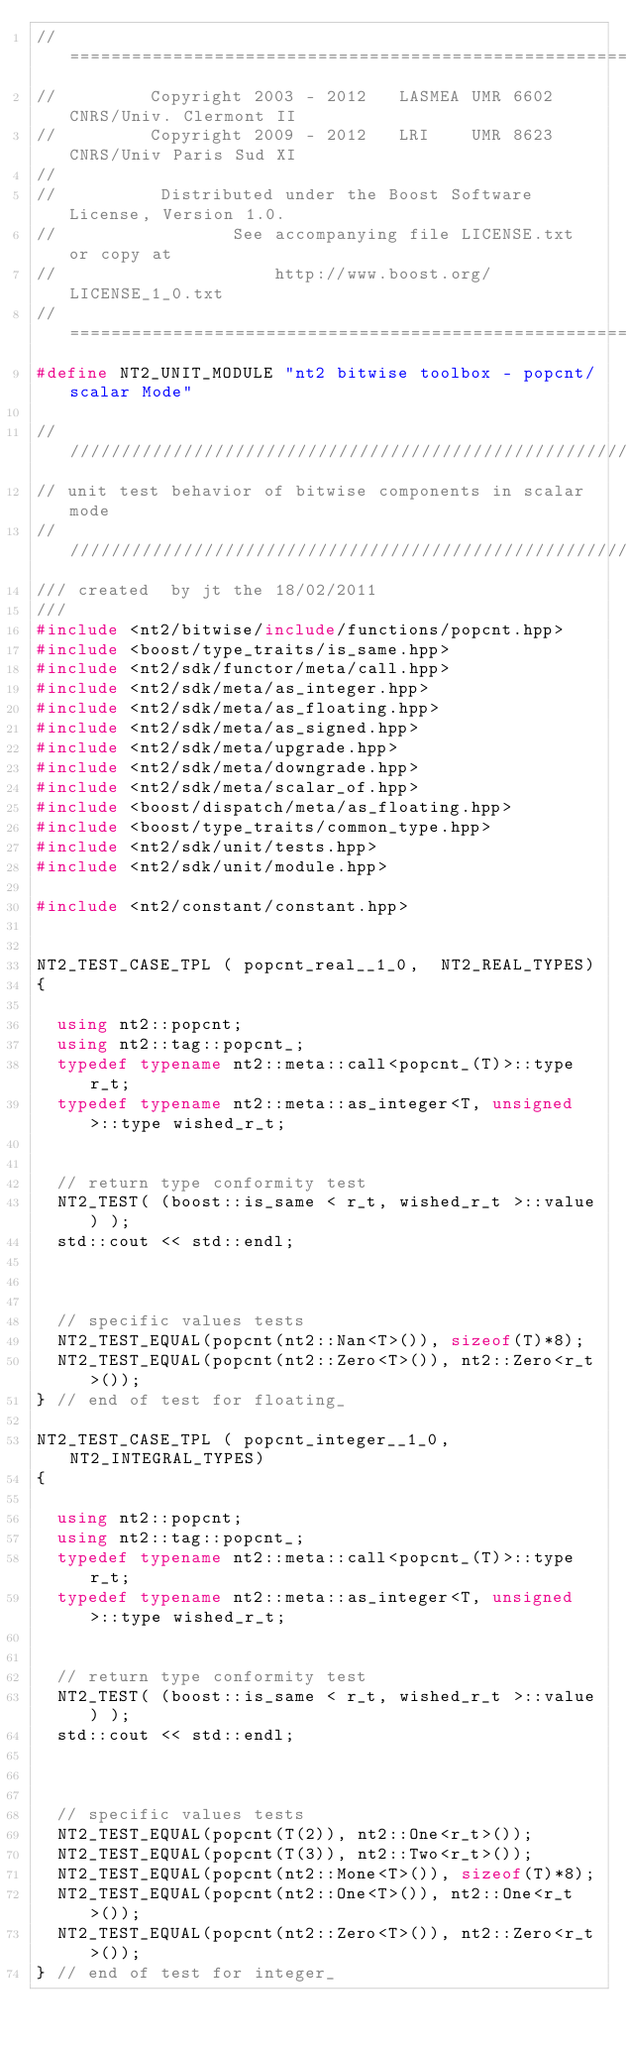Convert code to text. <code><loc_0><loc_0><loc_500><loc_500><_C++_>//==============================================================================
//         Copyright 2003 - 2012   LASMEA UMR 6602 CNRS/Univ. Clermont II
//         Copyright 2009 - 2012   LRI    UMR 8623 CNRS/Univ Paris Sud XI
//
//          Distributed under the Boost Software License, Version 1.0.
//                 See accompanying file LICENSE.txt or copy at
//                     http://www.boost.org/LICENSE_1_0.txt
//==============================================================================
#define NT2_UNIT_MODULE "nt2 bitwise toolbox - popcnt/scalar Mode"

//////////////////////////////////////////////////////////////////////////////
// unit test behavior of bitwise components in scalar mode
//////////////////////////////////////////////////////////////////////////////
/// created  by jt the 18/02/2011
///
#include <nt2/bitwise/include/functions/popcnt.hpp>
#include <boost/type_traits/is_same.hpp>
#include <nt2/sdk/functor/meta/call.hpp>
#include <nt2/sdk/meta/as_integer.hpp>
#include <nt2/sdk/meta/as_floating.hpp>
#include <nt2/sdk/meta/as_signed.hpp>
#include <nt2/sdk/meta/upgrade.hpp>
#include <nt2/sdk/meta/downgrade.hpp>
#include <nt2/sdk/meta/scalar_of.hpp>
#include <boost/dispatch/meta/as_floating.hpp>
#include <boost/type_traits/common_type.hpp>
#include <nt2/sdk/unit/tests.hpp>
#include <nt2/sdk/unit/module.hpp>

#include <nt2/constant/constant.hpp>


NT2_TEST_CASE_TPL ( popcnt_real__1_0,  NT2_REAL_TYPES)
{

  using nt2::popcnt;
  using nt2::tag::popcnt_;
  typedef typename nt2::meta::call<popcnt_(T)>::type r_t;
  typedef typename nt2::meta::as_integer<T, unsigned>::type wished_r_t;


  // return type conformity test
  NT2_TEST( (boost::is_same < r_t, wished_r_t >::value) );
  std::cout << std::endl;



  // specific values tests
  NT2_TEST_EQUAL(popcnt(nt2::Nan<T>()), sizeof(T)*8);
  NT2_TEST_EQUAL(popcnt(nt2::Zero<T>()), nt2::Zero<r_t>());
} // end of test for floating_

NT2_TEST_CASE_TPL ( popcnt_integer__1_0,  NT2_INTEGRAL_TYPES)
{

  using nt2::popcnt;
  using nt2::tag::popcnt_;
  typedef typename nt2::meta::call<popcnt_(T)>::type r_t;
  typedef typename nt2::meta::as_integer<T, unsigned>::type wished_r_t;


  // return type conformity test
  NT2_TEST( (boost::is_same < r_t, wished_r_t >::value) );
  std::cout << std::endl;



  // specific values tests
  NT2_TEST_EQUAL(popcnt(T(2)), nt2::One<r_t>());
  NT2_TEST_EQUAL(popcnt(T(3)), nt2::Two<r_t>());
  NT2_TEST_EQUAL(popcnt(nt2::Mone<T>()), sizeof(T)*8);
  NT2_TEST_EQUAL(popcnt(nt2::One<T>()), nt2::One<r_t>());
  NT2_TEST_EQUAL(popcnt(nt2::Zero<T>()), nt2::Zero<r_t>());
} // end of test for integer_
</code> 